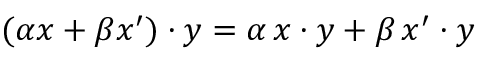<formula> <loc_0><loc_0><loc_500><loc_500>( \alpha x + \beta x ^ { \prime } ) \cdot y = \alpha \, x \cdot y + \beta \, x ^ { \prime } \cdot y</formula> 